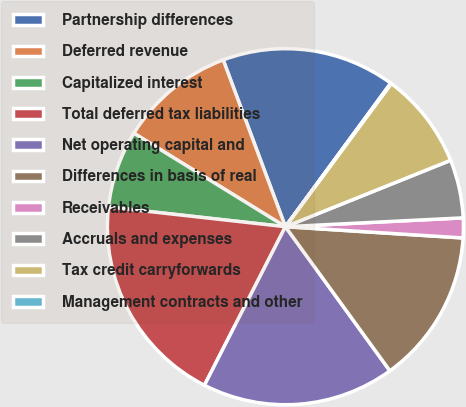Convert chart. <chart><loc_0><loc_0><loc_500><loc_500><pie_chart><fcel>Partnership differences<fcel>Deferred revenue<fcel>Capitalized interest<fcel>Total deferred tax liabilities<fcel>Net operating capital and<fcel>Differences in basis of real<fcel>Receivables<fcel>Accruals and expenses<fcel>Tax credit carryforwards<fcel>Management contracts and other<nl><fcel>15.76%<fcel>10.52%<fcel>7.03%<fcel>19.25%<fcel>17.5%<fcel>14.01%<fcel>1.8%<fcel>5.29%<fcel>8.78%<fcel>0.06%<nl></chart> 